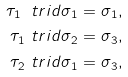<formula> <loc_0><loc_0><loc_500><loc_500>\tau _ { 1 } \ t r i d \sigma _ { 1 } & = \sigma _ { 1 } , \\ \tau _ { 1 } \ t r i d \sigma _ { 2 } & = \sigma _ { 3 } , \\ \tau _ { 2 } \ t r i d \sigma _ { 1 } & = \sigma _ { 3 } ,</formula> 